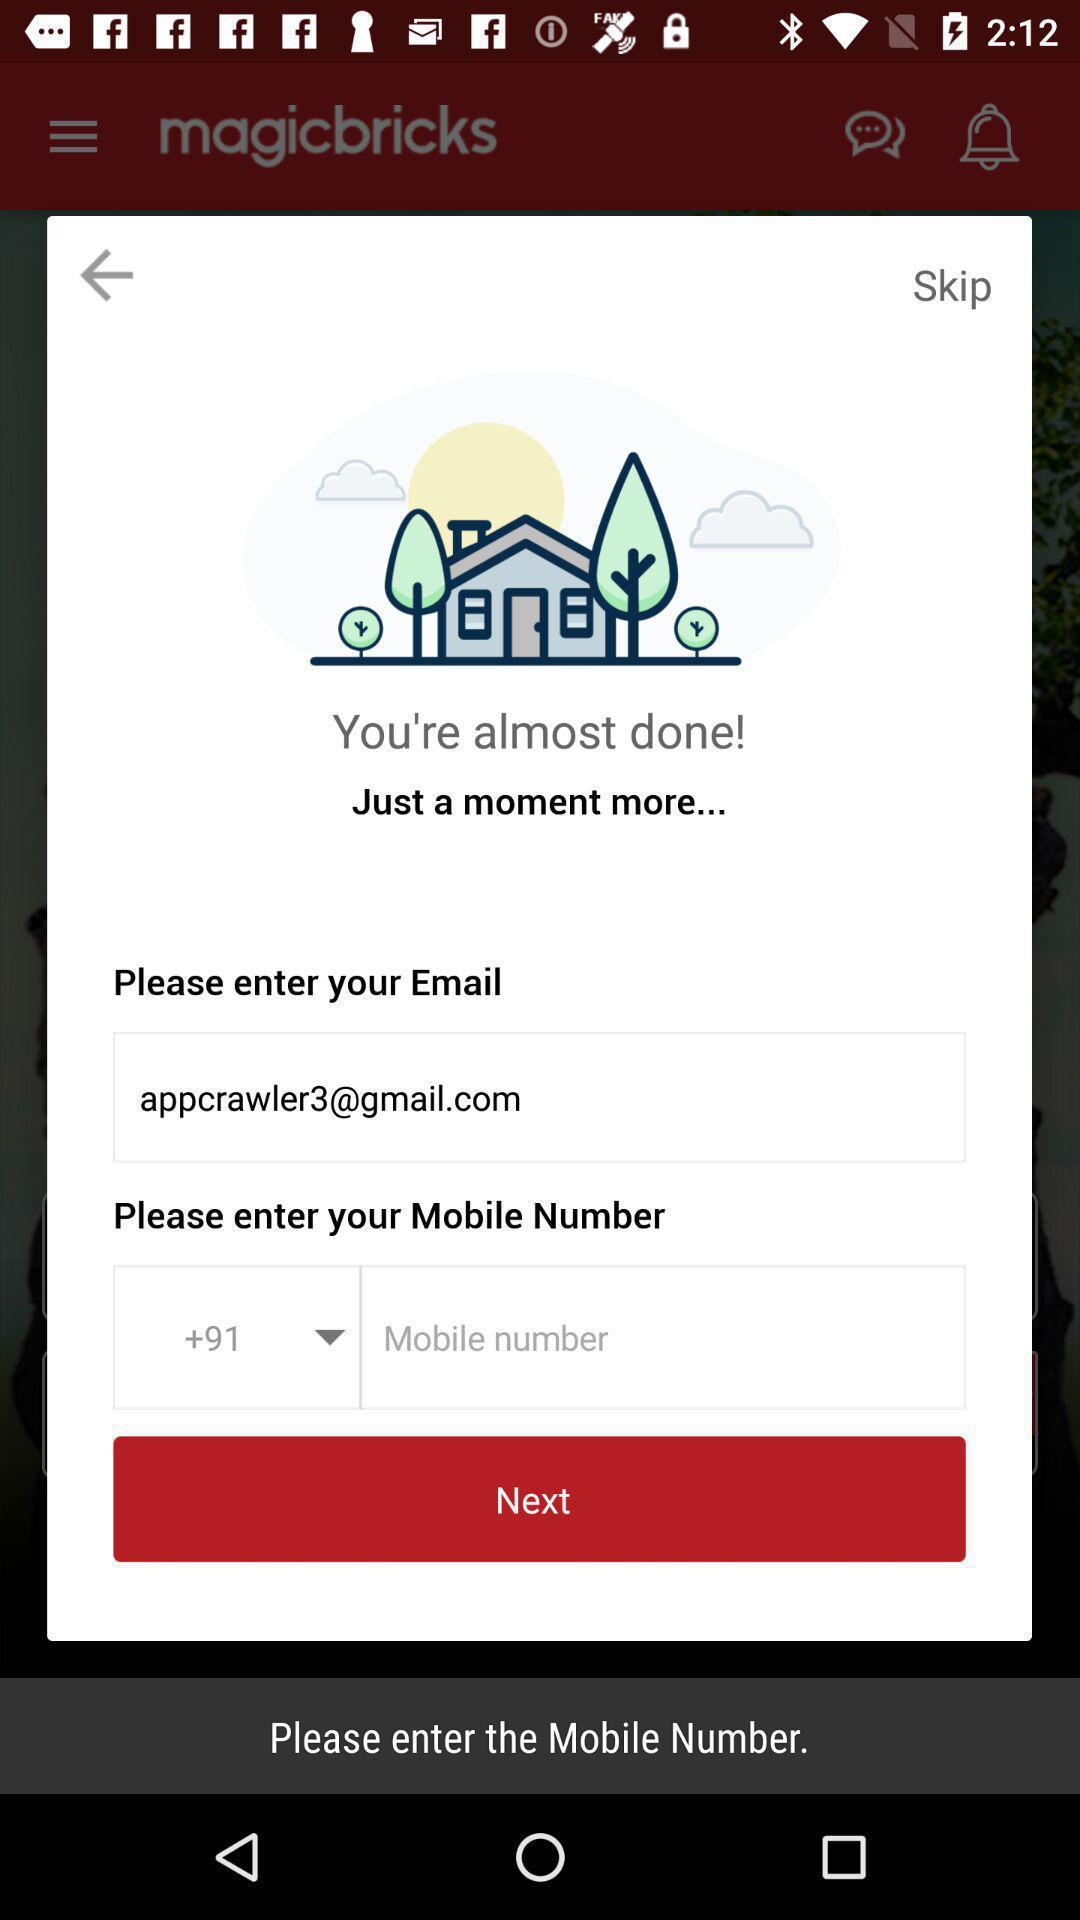What is the user's full phone number?
When the provided information is insufficient, respond with <no answer>. <no answer> 